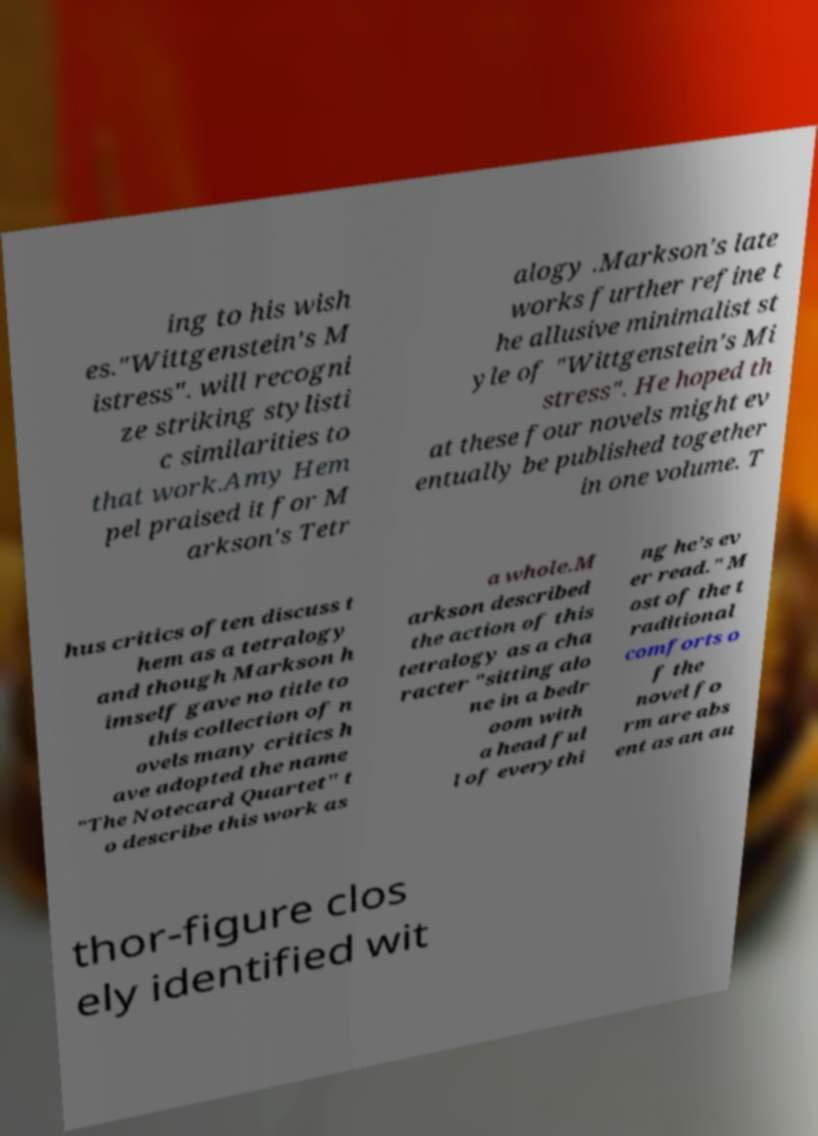Please read and relay the text visible in this image. What does it say? ing to his wish es."Wittgenstein's M istress". will recogni ze striking stylisti c similarities to that work.Amy Hem pel praised it for M arkson's Tetr alogy .Markson's late works further refine t he allusive minimalist st yle of "Wittgenstein's Mi stress". He hoped th at these four novels might ev entually be published together in one volume. T hus critics often discuss t hem as a tetralogy and though Markson h imself gave no title to this collection of n ovels many critics h ave adopted the name "The Notecard Quartet" t o describe this work as a whole.M arkson described the action of this tetralogy as a cha racter "sitting alo ne in a bedr oom with a head ful l of everythi ng he’s ev er read." M ost of the t raditional comforts o f the novel fo rm are abs ent as an au thor-figure clos ely identified wit 